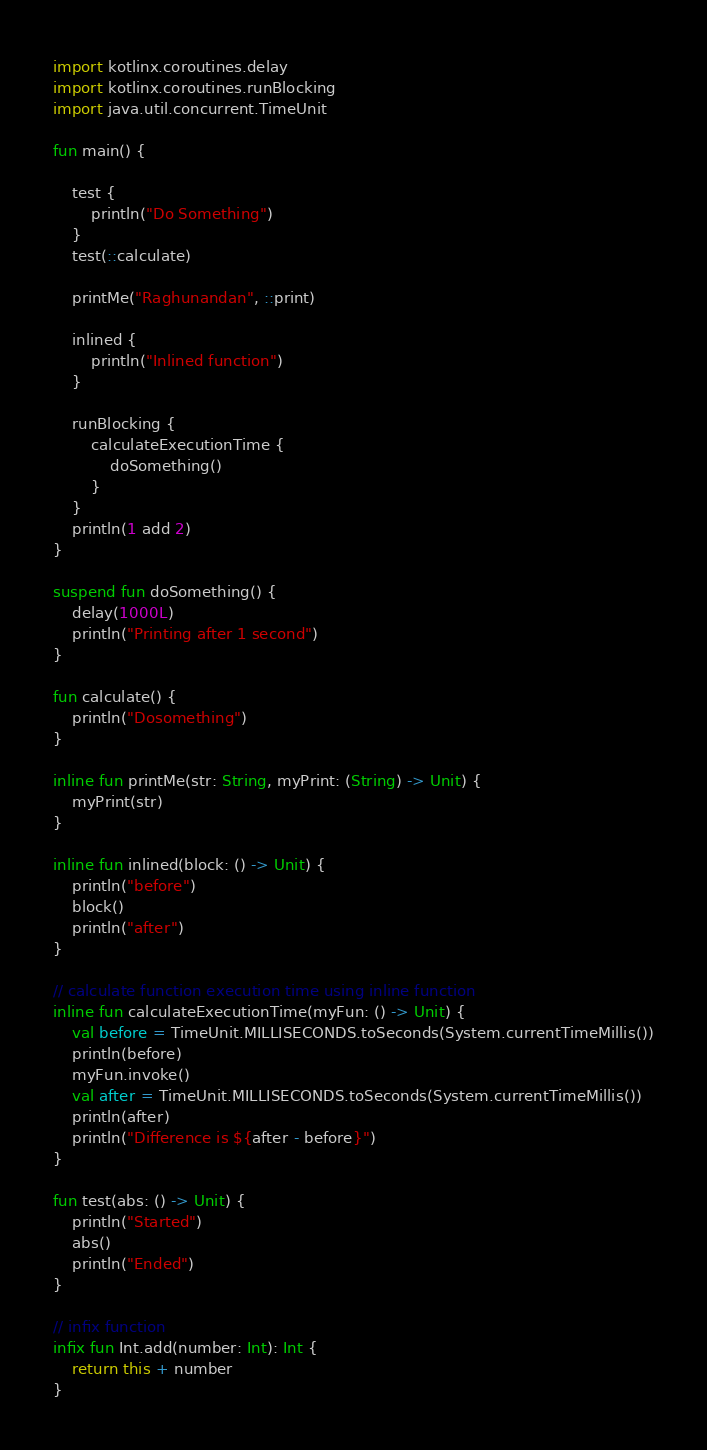<code> <loc_0><loc_0><loc_500><loc_500><_Kotlin_>import kotlinx.coroutines.delay
import kotlinx.coroutines.runBlocking
import java.util.concurrent.TimeUnit

fun main() {

    test {
        println("Do Something")
    }
    test(::calculate)

    printMe("Raghunandan", ::print)

    inlined {
        println("Inlined function")
    }

    runBlocking {
        calculateExecutionTime {
            doSomething()
        }
    }
    println(1 add 2)
}

suspend fun doSomething() {
    delay(1000L)
    println("Printing after 1 second")
}

fun calculate() {
    println("Dosomething")
}

inline fun printMe(str: String, myPrint: (String) -> Unit) {
    myPrint(str)
}

inline fun inlined(block: () -> Unit) {
    println("before")
    block()
    println("after")
}

// calculate function execution time using inline function
inline fun calculateExecutionTime(myFun: () -> Unit) {
    val before = TimeUnit.MILLISECONDS.toSeconds(System.currentTimeMillis())
    println(before)
    myFun.invoke()
    val after = TimeUnit.MILLISECONDS.toSeconds(System.currentTimeMillis())
    println(after)
    println("Difference is ${after - before}")
}

fun test(abs: () -> Unit) {
    println("Started")
    abs()
    println("Ended")
}

// infix function
infix fun Int.add(number: Int): Int {
    return this + number
}


</code> 